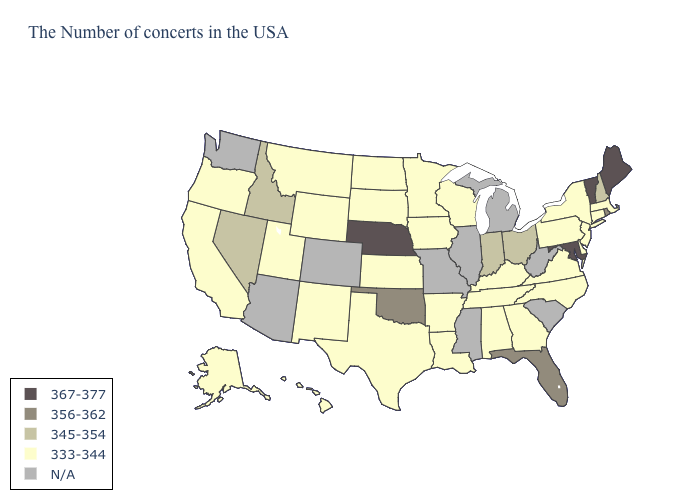Does Nevada have the lowest value in the West?
Quick response, please. No. Which states have the lowest value in the USA?
Be succinct. Massachusetts, Connecticut, New York, New Jersey, Delaware, Pennsylvania, Virginia, North Carolina, Georgia, Kentucky, Alabama, Tennessee, Wisconsin, Louisiana, Arkansas, Minnesota, Iowa, Kansas, Texas, South Dakota, North Dakota, Wyoming, New Mexico, Utah, Montana, California, Oregon, Alaska, Hawaii. Name the states that have a value in the range 356-362?
Concise answer only. Rhode Island, Florida, Oklahoma. Does the first symbol in the legend represent the smallest category?
Quick response, please. No. Does Nebraska have the highest value in the USA?
Give a very brief answer. Yes. Name the states that have a value in the range 345-354?
Give a very brief answer. New Hampshire, Ohio, Indiana, Idaho, Nevada. Does Idaho have the highest value in the West?
Answer briefly. Yes. Among the states that border Michigan , does Wisconsin have the highest value?
Concise answer only. No. What is the highest value in the USA?
Give a very brief answer. 367-377. Among the states that border South Carolina , which have the highest value?
Keep it brief. North Carolina, Georgia. What is the highest value in the USA?
Be succinct. 367-377. Name the states that have a value in the range 333-344?
Keep it brief. Massachusetts, Connecticut, New York, New Jersey, Delaware, Pennsylvania, Virginia, North Carolina, Georgia, Kentucky, Alabama, Tennessee, Wisconsin, Louisiana, Arkansas, Minnesota, Iowa, Kansas, Texas, South Dakota, North Dakota, Wyoming, New Mexico, Utah, Montana, California, Oregon, Alaska, Hawaii. Does Nebraska have the highest value in the USA?
Give a very brief answer. Yes. Is the legend a continuous bar?
Quick response, please. No. 